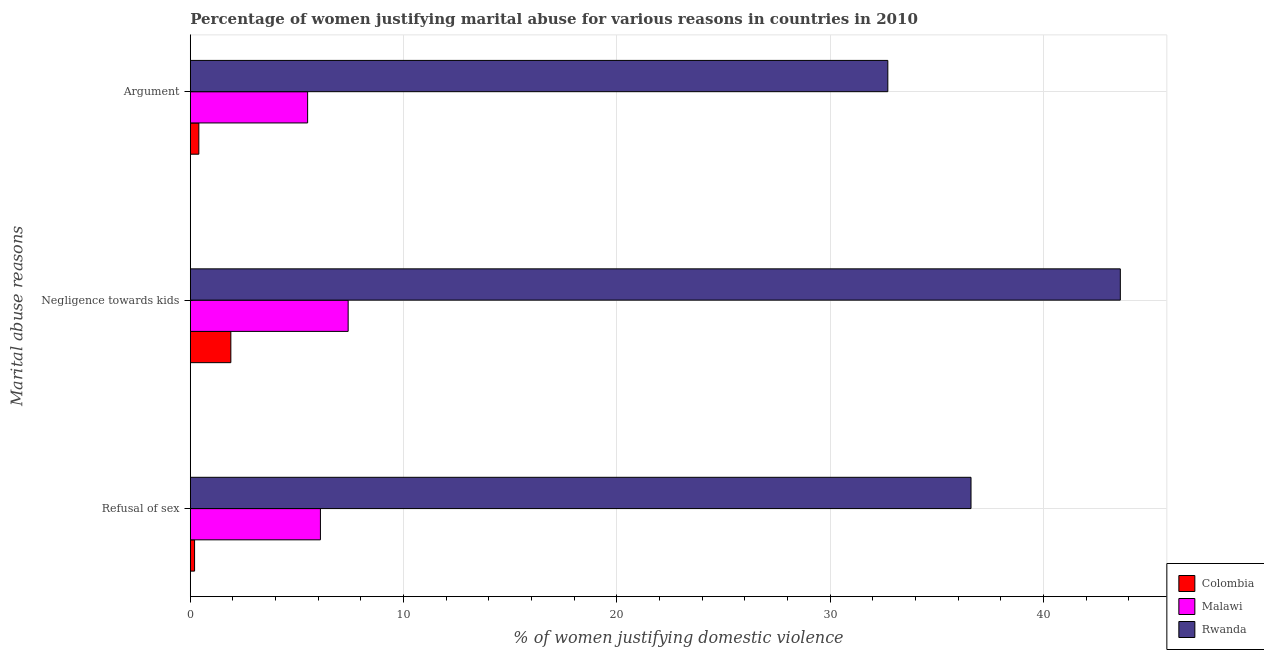How many different coloured bars are there?
Your answer should be compact. 3. Are the number of bars per tick equal to the number of legend labels?
Ensure brevity in your answer.  Yes. Are the number of bars on each tick of the Y-axis equal?
Ensure brevity in your answer.  Yes. How many bars are there on the 2nd tick from the top?
Make the answer very short. 3. How many bars are there on the 2nd tick from the bottom?
Provide a short and direct response. 3. What is the label of the 3rd group of bars from the top?
Give a very brief answer. Refusal of sex. What is the percentage of women justifying domestic violence due to negligence towards kids in Rwanda?
Make the answer very short. 43.6. Across all countries, what is the maximum percentage of women justifying domestic violence due to refusal of sex?
Offer a terse response. 36.6. Across all countries, what is the minimum percentage of women justifying domestic violence due to refusal of sex?
Give a very brief answer. 0.2. In which country was the percentage of women justifying domestic violence due to arguments maximum?
Make the answer very short. Rwanda. In which country was the percentage of women justifying domestic violence due to arguments minimum?
Provide a short and direct response. Colombia. What is the total percentage of women justifying domestic violence due to negligence towards kids in the graph?
Ensure brevity in your answer.  52.9. What is the difference between the percentage of women justifying domestic violence due to negligence towards kids in Rwanda and that in Colombia?
Provide a short and direct response. 41.7. What is the difference between the percentage of women justifying domestic violence due to refusal of sex in Malawi and the percentage of women justifying domestic violence due to arguments in Rwanda?
Your answer should be compact. -26.6. What is the average percentage of women justifying domestic violence due to negligence towards kids per country?
Your response must be concise. 17.63. In how many countries, is the percentage of women justifying domestic violence due to refusal of sex greater than 12 %?
Provide a succinct answer. 1. What is the ratio of the percentage of women justifying domestic violence due to negligence towards kids in Malawi to that in Rwanda?
Provide a short and direct response. 0.17. Is the percentage of women justifying domestic violence due to arguments in Malawi less than that in Colombia?
Offer a very short reply. No. What is the difference between the highest and the second highest percentage of women justifying domestic violence due to negligence towards kids?
Ensure brevity in your answer.  36.2. What is the difference between the highest and the lowest percentage of women justifying domestic violence due to arguments?
Provide a short and direct response. 32.3. In how many countries, is the percentage of women justifying domestic violence due to negligence towards kids greater than the average percentage of women justifying domestic violence due to negligence towards kids taken over all countries?
Offer a terse response. 1. Is the sum of the percentage of women justifying domestic violence due to refusal of sex in Colombia and Rwanda greater than the maximum percentage of women justifying domestic violence due to arguments across all countries?
Provide a short and direct response. Yes. What does the 2nd bar from the top in Negligence towards kids represents?
Offer a very short reply. Malawi. What does the 2nd bar from the bottom in Refusal of sex represents?
Provide a succinct answer. Malawi. How many bars are there?
Your answer should be compact. 9. Are all the bars in the graph horizontal?
Offer a terse response. Yes. How many countries are there in the graph?
Give a very brief answer. 3. What is the difference between two consecutive major ticks on the X-axis?
Your answer should be very brief. 10. Are the values on the major ticks of X-axis written in scientific E-notation?
Provide a succinct answer. No. How many legend labels are there?
Your answer should be very brief. 3. What is the title of the graph?
Keep it short and to the point. Percentage of women justifying marital abuse for various reasons in countries in 2010. Does "Micronesia" appear as one of the legend labels in the graph?
Provide a succinct answer. No. What is the label or title of the X-axis?
Keep it short and to the point. % of women justifying domestic violence. What is the label or title of the Y-axis?
Offer a terse response. Marital abuse reasons. What is the % of women justifying domestic violence in Colombia in Refusal of sex?
Offer a terse response. 0.2. What is the % of women justifying domestic violence in Malawi in Refusal of sex?
Your response must be concise. 6.1. What is the % of women justifying domestic violence in Rwanda in Refusal of sex?
Ensure brevity in your answer.  36.6. What is the % of women justifying domestic violence in Colombia in Negligence towards kids?
Your answer should be compact. 1.9. What is the % of women justifying domestic violence of Malawi in Negligence towards kids?
Your answer should be compact. 7.4. What is the % of women justifying domestic violence in Rwanda in Negligence towards kids?
Keep it short and to the point. 43.6. What is the % of women justifying domestic violence in Rwanda in Argument?
Offer a terse response. 32.7. Across all Marital abuse reasons, what is the maximum % of women justifying domestic violence in Colombia?
Offer a very short reply. 1.9. Across all Marital abuse reasons, what is the maximum % of women justifying domestic violence in Rwanda?
Ensure brevity in your answer.  43.6. Across all Marital abuse reasons, what is the minimum % of women justifying domestic violence of Colombia?
Ensure brevity in your answer.  0.2. Across all Marital abuse reasons, what is the minimum % of women justifying domestic violence of Rwanda?
Offer a terse response. 32.7. What is the total % of women justifying domestic violence in Colombia in the graph?
Provide a succinct answer. 2.5. What is the total % of women justifying domestic violence of Malawi in the graph?
Your response must be concise. 19. What is the total % of women justifying domestic violence in Rwanda in the graph?
Keep it short and to the point. 112.9. What is the difference between the % of women justifying domestic violence of Rwanda in Refusal of sex and that in Negligence towards kids?
Your answer should be very brief. -7. What is the difference between the % of women justifying domestic violence of Colombia in Refusal of sex and that in Argument?
Your response must be concise. -0.2. What is the difference between the % of women justifying domestic violence in Colombia in Negligence towards kids and that in Argument?
Your answer should be compact. 1.5. What is the difference between the % of women justifying domestic violence in Malawi in Negligence towards kids and that in Argument?
Offer a very short reply. 1.9. What is the difference between the % of women justifying domestic violence of Rwanda in Negligence towards kids and that in Argument?
Provide a short and direct response. 10.9. What is the difference between the % of women justifying domestic violence in Colombia in Refusal of sex and the % of women justifying domestic violence in Malawi in Negligence towards kids?
Your answer should be compact. -7.2. What is the difference between the % of women justifying domestic violence in Colombia in Refusal of sex and the % of women justifying domestic violence in Rwanda in Negligence towards kids?
Your response must be concise. -43.4. What is the difference between the % of women justifying domestic violence in Malawi in Refusal of sex and the % of women justifying domestic violence in Rwanda in Negligence towards kids?
Provide a succinct answer. -37.5. What is the difference between the % of women justifying domestic violence in Colombia in Refusal of sex and the % of women justifying domestic violence in Malawi in Argument?
Your response must be concise. -5.3. What is the difference between the % of women justifying domestic violence of Colombia in Refusal of sex and the % of women justifying domestic violence of Rwanda in Argument?
Make the answer very short. -32.5. What is the difference between the % of women justifying domestic violence of Malawi in Refusal of sex and the % of women justifying domestic violence of Rwanda in Argument?
Offer a very short reply. -26.6. What is the difference between the % of women justifying domestic violence of Colombia in Negligence towards kids and the % of women justifying domestic violence of Rwanda in Argument?
Your response must be concise. -30.8. What is the difference between the % of women justifying domestic violence in Malawi in Negligence towards kids and the % of women justifying domestic violence in Rwanda in Argument?
Give a very brief answer. -25.3. What is the average % of women justifying domestic violence of Malawi per Marital abuse reasons?
Provide a short and direct response. 6.33. What is the average % of women justifying domestic violence in Rwanda per Marital abuse reasons?
Provide a short and direct response. 37.63. What is the difference between the % of women justifying domestic violence of Colombia and % of women justifying domestic violence of Malawi in Refusal of sex?
Provide a short and direct response. -5.9. What is the difference between the % of women justifying domestic violence of Colombia and % of women justifying domestic violence of Rwanda in Refusal of sex?
Keep it short and to the point. -36.4. What is the difference between the % of women justifying domestic violence in Malawi and % of women justifying domestic violence in Rwanda in Refusal of sex?
Your answer should be very brief. -30.5. What is the difference between the % of women justifying domestic violence in Colombia and % of women justifying domestic violence in Malawi in Negligence towards kids?
Provide a short and direct response. -5.5. What is the difference between the % of women justifying domestic violence of Colombia and % of women justifying domestic violence of Rwanda in Negligence towards kids?
Give a very brief answer. -41.7. What is the difference between the % of women justifying domestic violence of Malawi and % of women justifying domestic violence of Rwanda in Negligence towards kids?
Ensure brevity in your answer.  -36.2. What is the difference between the % of women justifying domestic violence of Colombia and % of women justifying domestic violence of Rwanda in Argument?
Your answer should be very brief. -32.3. What is the difference between the % of women justifying domestic violence in Malawi and % of women justifying domestic violence in Rwanda in Argument?
Your answer should be very brief. -27.2. What is the ratio of the % of women justifying domestic violence of Colombia in Refusal of sex to that in Negligence towards kids?
Your response must be concise. 0.11. What is the ratio of the % of women justifying domestic violence in Malawi in Refusal of sex to that in Negligence towards kids?
Provide a short and direct response. 0.82. What is the ratio of the % of women justifying domestic violence of Rwanda in Refusal of sex to that in Negligence towards kids?
Your answer should be compact. 0.84. What is the ratio of the % of women justifying domestic violence in Malawi in Refusal of sex to that in Argument?
Your answer should be compact. 1.11. What is the ratio of the % of women justifying domestic violence in Rwanda in Refusal of sex to that in Argument?
Your answer should be very brief. 1.12. What is the ratio of the % of women justifying domestic violence of Colombia in Negligence towards kids to that in Argument?
Offer a very short reply. 4.75. What is the ratio of the % of women justifying domestic violence of Malawi in Negligence towards kids to that in Argument?
Provide a short and direct response. 1.35. What is the ratio of the % of women justifying domestic violence of Rwanda in Negligence towards kids to that in Argument?
Offer a very short reply. 1.33. What is the difference between the highest and the second highest % of women justifying domestic violence of Malawi?
Provide a succinct answer. 1.3. What is the difference between the highest and the lowest % of women justifying domestic violence of Colombia?
Offer a terse response. 1.7. What is the difference between the highest and the lowest % of women justifying domestic violence in Malawi?
Make the answer very short. 1.9. 